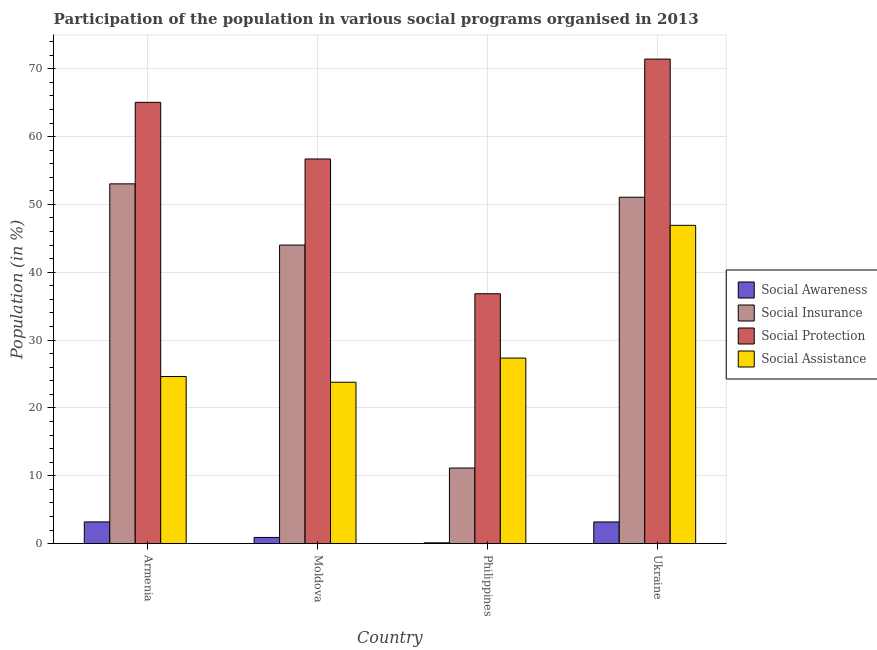How many different coloured bars are there?
Make the answer very short. 4. How many groups of bars are there?
Provide a short and direct response. 4. Are the number of bars per tick equal to the number of legend labels?
Provide a succinct answer. Yes. Are the number of bars on each tick of the X-axis equal?
Your response must be concise. Yes. How many bars are there on the 2nd tick from the left?
Your answer should be compact. 4. In how many cases, is the number of bars for a given country not equal to the number of legend labels?
Your answer should be very brief. 0. What is the participation of population in social protection programs in Moldova?
Provide a short and direct response. 56.7. Across all countries, what is the maximum participation of population in social assistance programs?
Your answer should be very brief. 46.92. Across all countries, what is the minimum participation of population in social awareness programs?
Make the answer very short. 0.12. In which country was the participation of population in social insurance programs maximum?
Ensure brevity in your answer.  Armenia. In which country was the participation of population in social insurance programs minimum?
Your answer should be very brief. Philippines. What is the total participation of population in social protection programs in the graph?
Provide a short and direct response. 230. What is the difference between the participation of population in social awareness programs in Philippines and that in Ukraine?
Make the answer very short. -3.08. What is the difference between the participation of population in social protection programs in Moldova and the participation of population in social insurance programs in Philippines?
Make the answer very short. 45.55. What is the average participation of population in social insurance programs per country?
Ensure brevity in your answer.  39.81. What is the difference between the participation of population in social protection programs and participation of population in social assistance programs in Ukraine?
Offer a terse response. 24.5. What is the ratio of the participation of population in social protection programs in Philippines to that in Ukraine?
Offer a terse response. 0.52. What is the difference between the highest and the second highest participation of population in social insurance programs?
Offer a terse response. 1.97. What is the difference between the highest and the lowest participation of population in social protection programs?
Give a very brief answer. 34.58. Is the sum of the participation of population in social assistance programs in Armenia and Moldova greater than the maximum participation of population in social insurance programs across all countries?
Provide a short and direct response. No. Is it the case that in every country, the sum of the participation of population in social protection programs and participation of population in social awareness programs is greater than the sum of participation of population in social assistance programs and participation of population in social insurance programs?
Keep it short and to the point. Yes. What does the 2nd bar from the left in Ukraine represents?
Keep it short and to the point. Social Insurance. What does the 1st bar from the right in Ukraine represents?
Provide a succinct answer. Social Assistance. Are all the bars in the graph horizontal?
Your response must be concise. No. How many countries are there in the graph?
Offer a terse response. 4. Are the values on the major ticks of Y-axis written in scientific E-notation?
Give a very brief answer. No. Does the graph contain any zero values?
Make the answer very short. No. How many legend labels are there?
Offer a very short reply. 4. What is the title of the graph?
Keep it short and to the point. Participation of the population in various social programs organised in 2013. What is the label or title of the X-axis?
Provide a succinct answer. Country. What is the Population (in %) in Social Awareness in Armenia?
Keep it short and to the point. 3.21. What is the Population (in %) of Social Insurance in Armenia?
Keep it short and to the point. 53.03. What is the Population (in %) of Social Protection in Armenia?
Provide a short and direct response. 65.04. What is the Population (in %) in Social Assistance in Armenia?
Make the answer very short. 24.63. What is the Population (in %) of Social Awareness in Moldova?
Ensure brevity in your answer.  0.92. What is the Population (in %) in Social Insurance in Moldova?
Give a very brief answer. 44.01. What is the Population (in %) in Social Protection in Moldova?
Keep it short and to the point. 56.7. What is the Population (in %) in Social Assistance in Moldova?
Ensure brevity in your answer.  23.79. What is the Population (in %) in Social Awareness in Philippines?
Give a very brief answer. 0.12. What is the Population (in %) in Social Insurance in Philippines?
Give a very brief answer. 11.15. What is the Population (in %) of Social Protection in Philippines?
Offer a very short reply. 36.84. What is the Population (in %) of Social Assistance in Philippines?
Provide a short and direct response. 27.35. What is the Population (in %) in Social Awareness in Ukraine?
Give a very brief answer. 3.2. What is the Population (in %) in Social Insurance in Ukraine?
Keep it short and to the point. 51.06. What is the Population (in %) in Social Protection in Ukraine?
Give a very brief answer. 71.42. What is the Population (in %) in Social Assistance in Ukraine?
Provide a succinct answer. 46.92. Across all countries, what is the maximum Population (in %) in Social Awareness?
Give a very brief answer. 3.21. Across all countries, what is the maximum Population (in %) of Social Insurance?
Provide a short and direct response. 53.03. Across all countries, what is the maximum Population (in %) of Social Protection?
Make the answer very short. 71.42. Across all countries, what is the maximum Population (in %) of Social Assistance?
Make the answer very short. 46.92. Across all countries, what is the minimum Population (in %) of Social Awareness?
Offer a very short reply. 0.12. Across all countries, what is the minimum Population (in %) in Social Insurance?
Keep it short and to the point. 11.15. Across all countries, what is the minimum Population (in %) in Social Protection?
Ensure brevity in your answer.  36.84. Across all countries, what is the minimum Population (in %) of Social Assistance?
Keep it short and to the point. 23.79. What is the total Population (in %) of Social Awareness in the graph?
Your answer should be compact. 7.45. What is the total Population (in %) of Social Insurance in the graph?
Give a very brief answer. 159.24. What is the total Population (in %) in Social Protection in the graph?
Keep it short and to the point. 230. What is the total Population (in %) of Social Assistance in the graph?
Provide a short and direct response. 122.7. What is the difference between the Population (in %) in Social Awareness in Armenia and that in Moldova?
Provide a short and direct response. 2.29. What is the difference between the Population (in %) in Social Insurance in Armenia and that in Moldova?
Make the answer very short. 9.03. What is the difference between the Population (in %) in Social Protection in Armenia and that in Moldova?
Your response must be concise. 8.34. What is the difference between the Population (in %) in Social Assistance in Armenia and that in Moldova?
Make the answer very short. 0.84. What is the difference between the Population (in %) in Social Awareness in Armenia and that in Philippines?
Provide a short and direct response. 3.08. What is the difference between the Population (in %) of Social Insurance in Armenia and that in Philippines?
Keep it short and to the point. 41.88. What is the difference between the Population (in %) in Social Protection in Armenia and that in Philippines?
Your answer should be very brief. 28.21. What is the difference between the Population (in %) of Social Assistance in Armenia and that in Philippines?
Keep it short and to the point. -2.72. What is the difference between the Population (in %) of Social Awareness in Armenia and that in Ukraine?
Your answer should be compact. 0. What is the difference between the Population (in %) of Social Insurance in Armenia and that in Ukraine?
Provide a succinct answer. 1.97. What is the difference between the Population (in %) in Social Protection in Armenia and that in Ukraine?
Provide a short and direct response. -6.38. What is the difference between the Population (in %) in Social Assistance in Armenia and that in Ukraine?
Offer a terse response. -22.28. What is the difference between the Population (in %) of Social Awareness in Moldova and that in Philippines?
Your response must be concise. 0.79. What is the difference between the Population (in %) in Social Insurance in Moldova and that in Philippines?
Ensure brevity in your answer.  32.86. What is the difference between the Population (in %) of Social Protection in Moldova and that in Philippines?
Provide a succinct answer. 19.86. What is the difference between the Population (in %) of Social Assistance in Moldova and that in Philippines?
Provide a short and direct response. -3.56. What is the difference between the Population (in %) of Social Awareness in Moldova and that in Ukraine?
Ensure brevity in your answer.  -2.29. What is the difference between the Population (in %) in Social Insurance in Moldova and that in Ukraine?
Provide a succinct answer. -7.05. What is the difference between the Population (in %) in Social Protection in Moldova and that in Ukraine?
Ensure brevity in your answer.  -14.72. What is the difference between the Population (in %) in Social Assistance in Moldova and that in Ukraine?
Ensure brevity in your answer.  -23.13. What is the difference between the Population (in %) in Social Awareness in Philippines and that in Ukraine?
Your answer should be very brief. -3.08. What is the difference between the Population (in %) of Social Insurance in Philippines and that in Ukraine?
Give a very brief answer. -39.91. What is the difference between the Population (in %) in Social Protection in Philippines and that in Ukraine?
Offer a terse response. -34.58. What is the difference between the Population (in %) of Social Assistance in Philippines and that in Ukraine?
Provide a short and direct response. -19.56. What is the difference between the Population (in %) of Social Awareness in Armenia and the Population (in %) of Social Insurance in Moldova?
Make the answer very short. -40.8. What is the difference between the Population (in %) of Social Awareness in Armenia and the Population (in %) of Social Protection in Moldova?
Give a very brief answer. -53.49. What is the difference between the Population (in %) of Social Awareness in Armenia and the Population (in %) of Social Assistance in Moldova?
Ensure brevity in your answer.  -20.59. What is the difference between the Population (in %) of Social Insurance in Armenia and the Population (in %) of Social Protection in Moldova?
Make the answer very short. -3.67. What is the difference between the Population (in %) of Social Insurance in Armenia and the Population (in %) of Social Assistance in Moldova?
Keep it short and to the point. 29.24. What is the difference between the Population (in %) in Social Protection in Armenia and the Population (in %) in Social Assistance in Moldova?
Your answer should be compact. 41.25. What is the difference between the Population (in %) in Social Awareness in Armenia and the Population (in %) in Social Insurance in Philippines?
Keep it short and to the point. -7.94. What is the difference between the Population (in %) in Social Awareness in Armenia and the Population (in %) in Social Protection in Philippines?
Provide a succinct answer. -33.63. What is the difference between the Population (in %) of Social Awareness in Armenia and the Population (in %) of Social Assistance in Philippines?
Offer a terse response. -24.15. What is the difference between the Population (in %) of Social Insurance in Armenia and the Population (in %) of Social Protection in Philippines?
Offer a terse response. 16.2. What is the difference between the Population (in %) in Social Insurance in Armenia and the Population (in %) in Social Assistance in Philippines?
Ensure brevity in your answer.  25.68. What is the difference between the Population (in %) of Social Protection in Armenia and the Population (in %) of Social Assistance in Philippines?
Provide a succinct answer. 37.69. What is the difference between the Population (in %) in Social Awareness in Armenia and the Population (in %) in Social Insurance in Ukraine?
Provide a succinct answer. -47.85. What is the difference between the Population (in %) in Social Awareness in Armenia and the Population (in %) in Social Protection in Ukraine?
Provide a short and direct response. -68.21. What is the difference between the Population (in %) in Social Awareness in Armenia and the Population (in %) in Social Assistance in Ukraine?
Offer a very short reply. -43.71. What is the difference between the Population (in %) in Social Insurance in Armenia and the Population (in %) in Social Protection in Ukraine?
Offer a terse response. -18.39. What is the difference between the Population (in %) in Social Insurance in Armenia and the Population (in %) in Social Assistance in Ukraine?
Provide a succinct answer. 6.11. What is the difference between the Population (in %) in Social Protection in Armenia and the Population (in %) in Social Assistance in Ukraine?
Your answer should be compact. 18.13. What is the difference between the Population (in %) in Social Awareness in Moldova and the Population (in %) in Social Insurance in Philippines?
Provide a short and direct response. -10.23. What is the difference between the Population (in %) of Social Awareness in Moldova and the Population (in %) of Social Protection in Philippines?
Offer a very short reply. -35.92. What is the difference between the Population (in %) of Social Awareness in Moldova and the Population (in %) of Social Assistance in Philippines?
Ensure brevity in your answer.  -26.44. What is the difference between the Population (in %) in Social Insurance in Moldova and the Population (in %) in Social Protection in Philippines?
Make the answer very short. 7.17. What is the difference between the Population (in %) of Social Insurance in Moldova and the Population (in %) of Social Assistance in Philippines?
Your answer should be compact. 16.65. What is the difference between the Population (in %) of Social Protection in Moldova and the Population (in %) of Social Assistance in Philippines?
Your answer should be very brief. 29.34. What is the difference between the Population (in %) of Social Awareness in Moldova and the Population (in %) of Social Insurance in Ukraine?
Offer a very short reply. -50.14. What is the difference between the Population (in %) in Social Awareness in Moldova and the Population (in %) in Social Protection in Ukraine?
Your response must be concise. -70.5. What is the difference between the Population (in %) in Social Awareness in Moldova and the Population (in %) in Social Assistance in Ukraine?
Offer a terse response. -46. What is the difference between the Population (in %) in Social Insurance in Moldova and the Population (in %) in Social Protection in Ukraine?
Ensure brevity in your answer.  -27.41. What is the difference between the Population (in %) of Social Insurance in Moldova and the Population (in %) of Social Assistance in Ukraine?
Give a very brief answer. -2.91. What is the difference between the Population (in %) of Social Protection in Moldova and the Population (in %) of Social Assistance in Ukraine?
Offer a terse response. 9.78. What is the difference between the Population (in %) in Social Awareness in Philippines and the Population (in %) in Social Insurance in Ukraine?
Provide a short and direct response. -50.94. What is the difference between the Population (in %) of Social Awareness in Philippines and the Population (in %) of Social Protection in Ukraine?
Offer a terse response. -71.3. What is the difference between the Population (in %) in Social Awareness in Philippines and the Population (in %) in Social Assistance in Ukraine?
Your answer should be very brief. -46.79. What is the difference between the Population (in %) in Social Insurance in Philippines and the Population (in %) in Social Protection in Ukraine?
Ensure brevity in your answer.  -60.27. What is the difference between the Population (in %) in Social Insurance in Philippines and the Population (in %) in Social Assistance in Ukraine?
Your answer should be compact. -35.77. What is the difference between the Population (in %) of Social Protection in Philippines and the Population (in %) of Social Assistance in Ukraine?
Provide a short and direct response. -10.08. What is the average Population (in %) of Social Awareness per country?
Give a very brief answer. 1.86. What is the average Population (in %) in Social Insurance per country?
Keep it short and to the point. 39.81. What is the average Population (in %) in Social Protection per country?
Your answer should be compact. 57.5. What is the average Population (in %) in Social Assistance per country?
Offer a terse response. 30.67. What is the difference between the Population (in %) of Social Awareness and Population (in %) of Social Insurance in Armenia?
Your answer should be very brief. -49.83. What is the difference between the Population (in %) in Social Awareness and Population (in %) in Social Protection in Armenia?
Make the answer very short. -61.84. What is the difference between the Population (in %) in Social Awareness and Population (in %) in Social Assistance in Armenia?
Provide a short and direct response. -21.43. What is the difference between the Population (in %) in Social Insurance and Population (in %) in Social Protection in Armenia?
Keep it short and to the point. -12.01. What is the difference between the Population (in %) of Social Insurance and Population (in %) of Social Assistance in Armenia?
Ensure brevity in your answer.  28.4. What is the difference between the Population (in %) in Social Protection and Population (in %) in Social Assistance in Armenia?
Your response must be concise. 40.41. What is the difference between the Population (in %) of Social Awareness and Population (in %) of Social Insurance in Moldova?
Your response must be concise. -43.09. What is the difference between the Population (in %) in Social Awareness and Population (in %) in Social Protection in Moldova?
Offer a terse response. -55.78. What is the difference between the Population (in %) in Social Awareness and Population (in %) in Social Assistance in Moldova?
Offer a very short reply. -22.88. What is the difference between the Population (in %) in Social Insurance and Population (in %) in Social Protection in Moldova?
Your answer should be very brief. -12.69. What is the difference between the Population (in %) in Social Insurance and Population (in %) in Social Assistance in Moldova?
Offer a terse response. 20.21. What is the difference between the Population (in %) of Social Protection and Population (in %) of Social Assistance in Moldova?
Offer a very short reply. 32.91. What is the difference between the Population (in %) of Social Awareness and Population (in %) of Social Insurance in Philippines?
Keep it short and to the point. -11.02. What is the difference between the Population (in %) of Social Awareness and Population (in %) of Social Protection in Philippines?
Offer a very short reply. -36.71. What is the difference between the Population (in %) of Social Awareness and Population (in %) of Social Assistance in Philippines?
Your response must be concise. -27.23. What is the difference between the Population (in %) in Social Insurance and Population (in %) in Social Protection in Philippines?
Make the answer very short. -25.69. What is the difference between the Population (in %) of Social Insurance and Population (in %) of Social Assistance in Philippines?
Your response must be concise. -16.21. What is the difference between the Population (in %) in Social Protection and Population (in %) in Social Assistance in Philippines?
Offer a very short reply. 9.48. What is the difference between the Population (in %) of Social Awareness and Population (in %) of Social Insurance in Ukraine?
Your answer should be compact. -47.86. What is the difference between the Population (in %) in Social Awareness and Population (in %) in Social Protection in Ukraine?
Offer a very short reply. -68.22. What is the difference between the Population (in %) in Social Awareness and Population (in %) in Social Assistance in Ukraine?
Your answer should be compact. -43.72. What is the difference between the Population (in %) in Social Insurance and Population (in %) in Social Protection in Ukraine?
Keep it short and to the point. -20.36. What is the difference between the Population (in %) of Social Insurance and Population (in %) of Social Assistance in Ukraine?
Your response must be concise. 4.14. What is the difference between the Population (in %) of Social Protection and Population (in %) of Social Assistance in Ukraine?
Your answer should be very brief. 24.5. What is the ratio of the Population (in %) of Social Awareness in Armenia to that in Moldova?
Provide a succinct answer. 3.5. What is the ratio of the Population (in %) of Social Insurance in Armenia to that in Moldova?
Offer a terse response. 1.21. What is the ratio of the Population (in %) of Social Protection in Armenia to that in Moldova?
Make the answer very short. 1.15. What is the ratio of the Population (in %) in Social Assistance in Armenia to that in Moldova?
Offer a very short reply. 1.04. What is the ratio of the Population (in %) of Social Awareness in Armenia to that in Philippines?
Your answer should be compact. 26.09. What is the ratio of the Population (in %) of Social Insurance in Armenia to that in Philippines?
Offer a terse response. 4.76. What is the ratio of the Population (in %) in Social Protection in Armenia to that in Philippines?
Ensure brevity in your answer.  1.77. What is the ratio of the Population (in %) of Social Assistance in Armenia to that in Philippines?
Provide a succinct answer. 0.9. What is the ratio of the Population (in %) in Social Awareness in Armenia to that in Ukraine?
Keep it short and to the point. 1. What is the ratio of the Population (in %) in Social Insurance in Armenia to that in Ukraine?
Ensure brevity in your answer.  1.04. What is the ratio of the Population (in %) in Social Protection in Armenia to that in Ukraine?
Make the answer very short. 0.91. What is the ratio of the Population (in %) in Social Assistance in Armenia to that in Ukraine?
Give a very brief answer. 0.53. What is the ratio of the Population (in %) of Social Awareness in Moldova to that in Philippines?
Keep it short and to the point. 7.45. What is the ratio of the Population (in %) of Social Insurance in Moldova to that in Philippines?
Give a very brief answer. 3.95. What is the ratio of the Population (in %) in Social Protection in Moldova to that in Philippines?
Ensure brevity in your answer.  1.54. What is the ratio of the Population (in %) in Social Assistance in Moldova to that in Philippines?
Give a very brief answer. 0.87. What is the ratio of the Population (in %) of Social Awareness in Moldova to that in Ukraine?
Make the answer very short. 0.29. What is the ratio of the Population (in %) in Social Insurance in Moldova to that in Ukraine?
Offer a very short reply. 0.86. What is the ratio of the Population (in %) in Social Protection in Moldova to that in Ukraine?
Your answer should be compact. 0.79. What is the ratio of the Population (in %) in Social Assistance in Moldova to that in Ukraine?
Ensure brevity in your answer.  0.51. What is the ratio of the Population (in %) of Social Awareness in Philippines to that in Ukraine?
Ensure brevity in your answer.  0.04. What is the ratio of the Population (in %) in Social Insurance in Philippines to that in Ukraine?
Your response must be concise. 0.22. What is the ratio of the Population (in %) in Social Protection in Philippines to that in Ukraine?
Give a very brief answer. 0.52. What is the ratio of the Population (in %) of Social Assistance in Philippines to that in Ukraine?
Provide a succinct answer. 0.58. What is the difference between the highest and the second highest Population (in %) in Social Awareness?
Ensure brevity in your answer.  0. What is the difference between the highest and the second highest Population (in %) in Social Insurance?
Keep it short and to the point. 1.97. What is the difference between the highest and the second highest Population (in %) of Social Protection?
Your answer should be very brief. 6.38. What is the difference between the highest and the second highest Population (in %) of Social Assistance?
Offer a very short reply. 19.56. What is the difference between the highest and the lowest Population (in %) in Social Awareness?
Your response must be concise. 3.08. What is the difference between the highest and the lowest Population (in %) of Social Insurance?
Offer a terse response. 41.88. What is the difference between the highest and the lowest Population (in %) of Social Protection?
Your answer should be compact. 34.58. What is the difference between the highest and the lowest Population (in %) in Social Assistance?
Offer a very short reply. 23.13. 